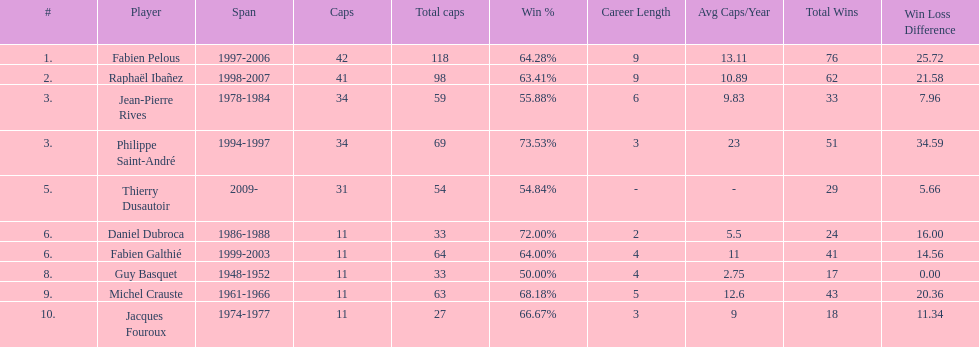How many captains played 11 capped matches? 5. 